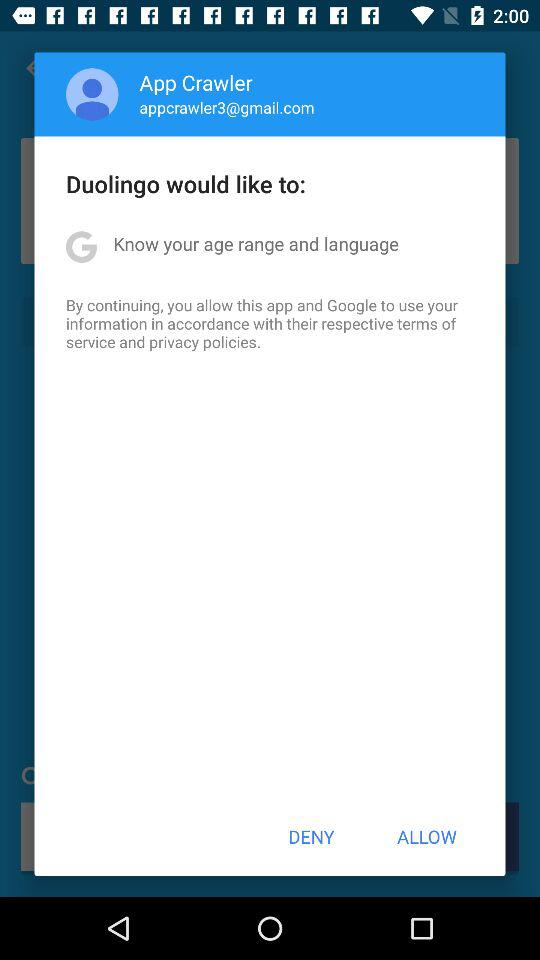What is the name of the user? The name of the user is App Crawler. 